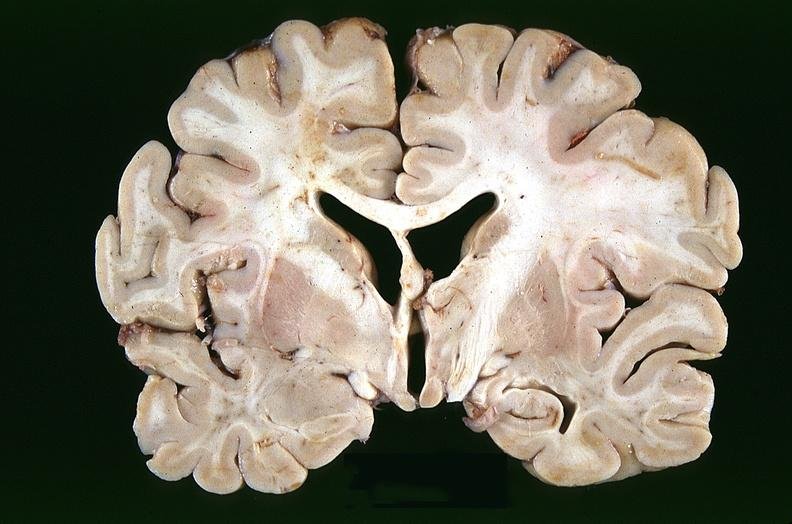s nervous present?
Answer the question using a single word or phrase. Yes 